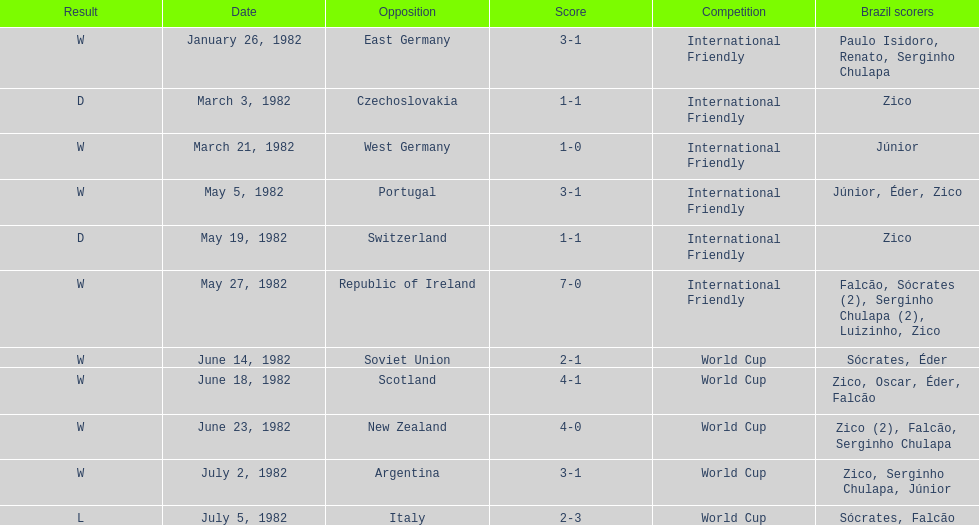How many games did this team play in 1982? 11. 